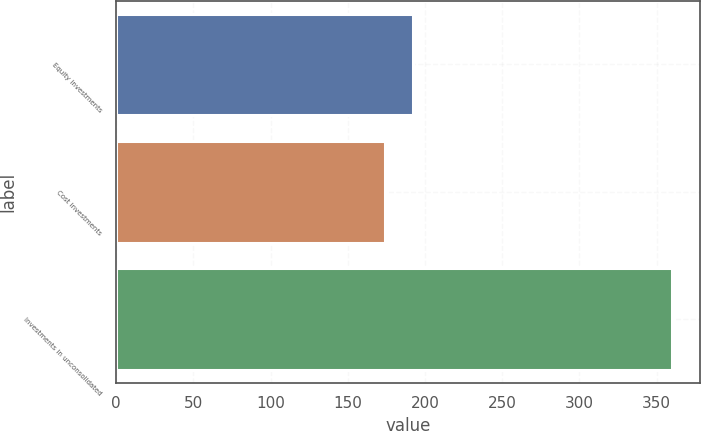Convert chart. <chart><loc_0><loc_0><loc_500><loc_500><bar_chart><fcel>Equity investments<fcel>Cost investments<fcel>Investments in unconsolidated<nl><fcel>192.6<fcel>174<fcel>360<nl></chart> 